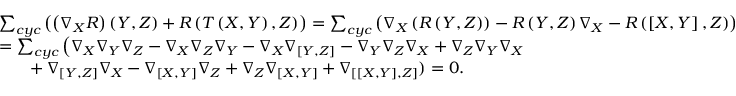<formula> <loc_0><loc_0><loc_500><loc_500>\begin{array} { r l } & { \sum _ { c y c } \left ( \left ( \nabla _ { X } R \right ) \left ( Y , Z \right ) + R \left ( T \left ( X , Y \right ) , Z \right ) \right ) = \sum _ { c y c } \left ( \nabla _ { X } \left ( R \left ( Y , Z \right ) \right ) - R \left ( Y , Z \right ) \nabla _ { X } - R \left ( \left [ X , Y \right ] , Z \right ) \right ) } \\ & { = \sum _ { c y c } \left ( \nabla _ { X } \nabla _ { Y } \nabla _ { Z } - \nabla _ { X } \nabla _ { Z } \nabla _ { Y } - \nabla _ { X } \nabla _ { \left [ Y , Z \right ] } - \nabla _ { Y } \nabla _ { Z } \nabla _ { X } + \nabla _ { Z } \nabla _ { Y } \nabla _ { X } } \\ & { \quad + \nabla _ { \left [ Y , Z \right ] } \nabla _ { X } - \nabla _ { \left [ X , Y \right ] } \nabla _ { Z } + \nabla _ { Z } \nabla _ { \left [ X , Y \right ] } + \nabla _ { \left [ \left [ X , Y \right ] , Z \right ] } ) = 0 . } \end{array}</formula> 